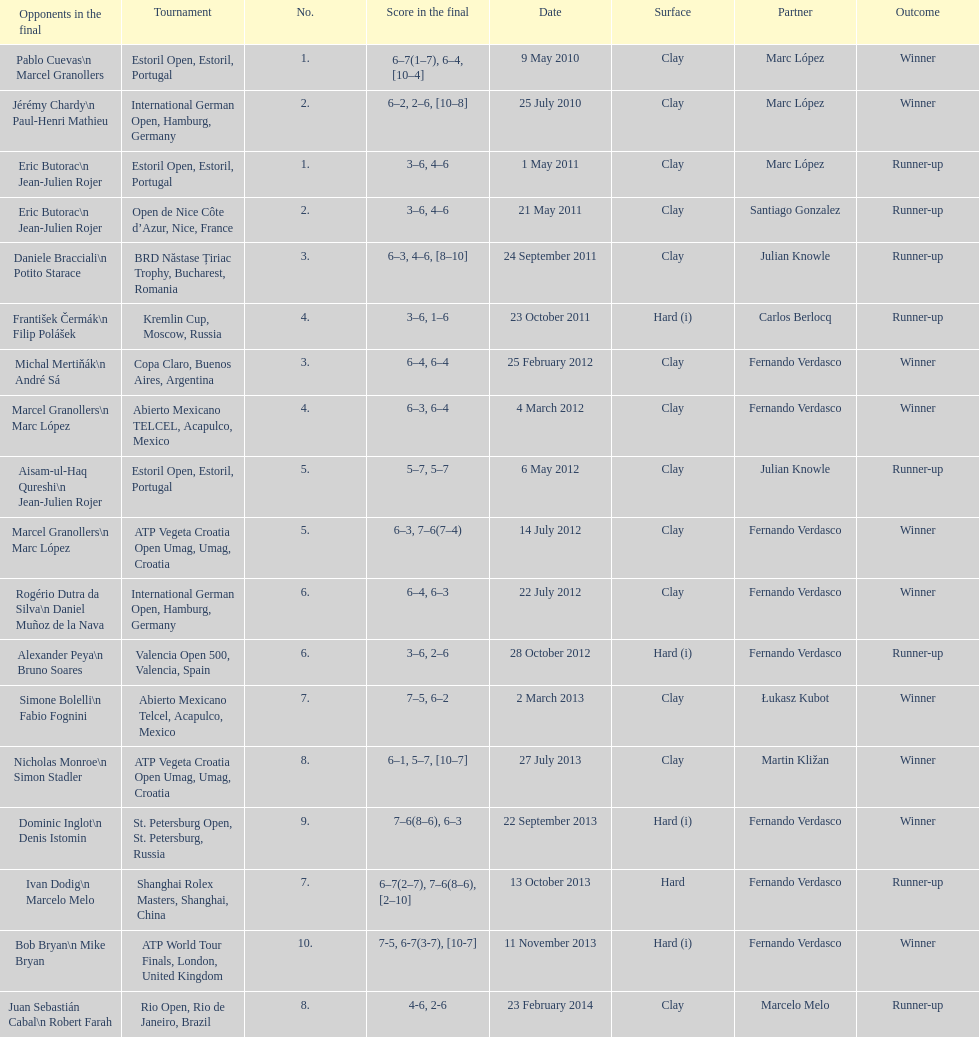Could you help me parse every detail presented in this table? {'header': ['Opponents in the final', 'Tournament', 'No.', 'Score in the final', 'Date', 'Surface', 'Partner', 'Outcome'], 'rows': [['Pablo Cuevas\\n Marcel Granollers', 'Estoril Open, Estoril, Portugal', '1.', '6–7(1–7), 6–4, [10–4]', '9 May 2010', 'Clay', 'Marc López', 'Winner'], ['Jérémy Chardy\\n Paul-Henri Mathieu', 'International German Open, Hamburg, Germany', '2.', '6–2, 2–6, [10–8]', '25 July 2010', 'Clay', 'Marc López', 'Winner'], ['Eric Butorac\\n Jean-Julien Rojer', 'Estoril Open, Estoril, Portugal', '1.', '3–6, 4–6', '1 May 2011', 'Clay', 'Marc López', 'Runner-up'], ['Eric Butorac\\n Jean-Julien Rojer', 'Open de Nice Côte d’Azur, Nice, France', '2.', '3–6, 4–6', '21 May 2011', 'Clay', 'Santiago Gonzalez', 'Runner-up'], ['Daniele Bracciali\\n Potito Starace', 'BRD Năstase Țiriac Trophy, Bucharest, Romania', '3.', '6–3, 4–6, [8–10]', '24 September 2011', 'Clay', 'Julian Knowle', 'Runner-up'], ['František Čermák\\n Filip Polášek', 'Kremlin Cup, Moscow, Russia', '4.', '3–6, 1–6', '23 October 2011', 'Hard (i)', 'Carlos Berlocq', 'Runner-up'], ['Michal Mertiňák\\n André Sá', 'Copa Claro, Buenos Aires, Argentina', '3.', '6–4, 6–4', '25 February 2012', 'Clay', 'Fernando Verdasco', 'Winner'], ['Marcel Granollers\\n Marc López', 'Abierto Mexicano TELCEL, Acapulco, Mexico', '4.', '6–3, 6–4', '4 March 2012', 'Clay', 'Fernando Verdasco', 'Winner'], ['Aisam-ul-Haq Qureshi\\n Jean-Julien Rojer', 'Estoril Open, Estoril, Portugal', '5.', '5–7, 5–7', '6 May 2012', 'Clay', 'Julian Knowle', 'Runner-up'], ['Marcel Granollers\\n Marc López', 'ATP Vegeta Croatia Open Umag, Umag, Croatia', '5.', '6–3, 7–6(7–4)', '14 July 2012', 'Clay', 'Fernando Verdasco', 'Winner'], ['Rogério Dutra da Silva\\n Daniel Muñoz de la Nava', 'International German Open, Hamburg, Germany', '6.', '6–4, 6–3', '22 July 2012', 'Clay', 'Fernando Verdasco', 'Winner'], ['Alexander Peya\\n Bruno Soares', 'Valencia Open 500, Valencia, Spain', '6.', '3–6, 2–6', '28 October 2012', 'Hard (i)', 'Fernando Verdasco', 'Runner-up'], ['Simone Bolelli\\n Fabio Fognini', 'Abierto Mexicano Telcel, Acapulco, Mexico', '7.', '7–5, 6–2', '2 March 2013', 'Clay', 'Łukasz Kubot', 'Winner'], ['Nicholas Monroe\\n Simon Stadler', 'ATP Vegeta Croatia Open Umag, Umag, Croatia', '8.', '6–1, 5–7, [10–7]', '27 July 2013', 'Clay', 'Martin Kližan', 'Winner'], ['Dominic Inglot\\n Denis Istomin', 'St. Petersburg Open, St. Petersburg, Russia', '9.', '7–6(8–6), 6–3', '22 September 2013', 'Hard (i)', 'Fernando Verdasco', 'Winner'], ['Ivan Dodig\\n Marcelo Melo', 'Shanghai Rolex Masters, Shanghai, China', '7.', '6–7(2–7), 7–6(8–6), [2–10]', '13 October 2013', 'Hard', 'Fernando Verdasco', 'Runner-up'], ['Bob Bryan\\n Mike Bryan', 'ATP World Tour Finals, London, United Kingdom', '10.', '7-5, 6-7(3-7), [10-7]', '11 November 2013', 'Hard (i)', 'Fernando Verdasco', 'Winner'], ['Juan Sebastián Cabal\\n Robert Farah', 'Rio Open, Rio de Janeiro, Brazil', '8.', '4-6, 2-6', '23 February 2014', 'Clay', 'Marcelo Melo', 'Runner-up']]} Who won both the st.petersburg open and the atp world tour finals? Fernando Verdasco. 